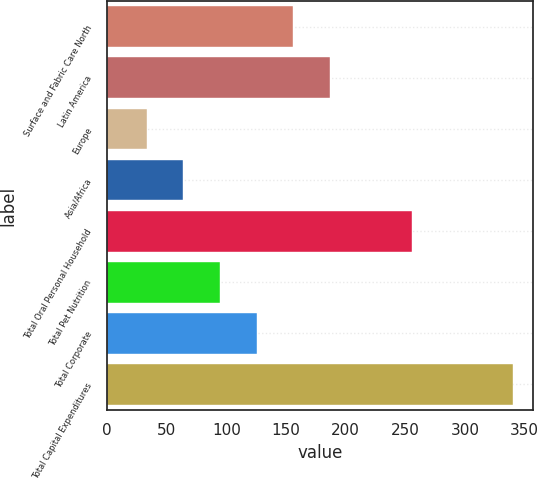<chart> <loc_0><loc_0><loc_500><loc_500><bar_chart><fcel>Surface and Fabric Care North<fcel>Latin America<fcel>Europe<fcel>Asia/Africa<fcel>Total Oral Personal Household<fcel>Total Pet Nutrition<fcel>Total Corporate<fcel>Total Capital Expenditures<nl><fcel>156.06<fcel>186.75<fcel>33.3<fcel>63.99<fcel>255.9<fcel>94.68<fcel>125.37<fcel>340.2<nl></chart> 